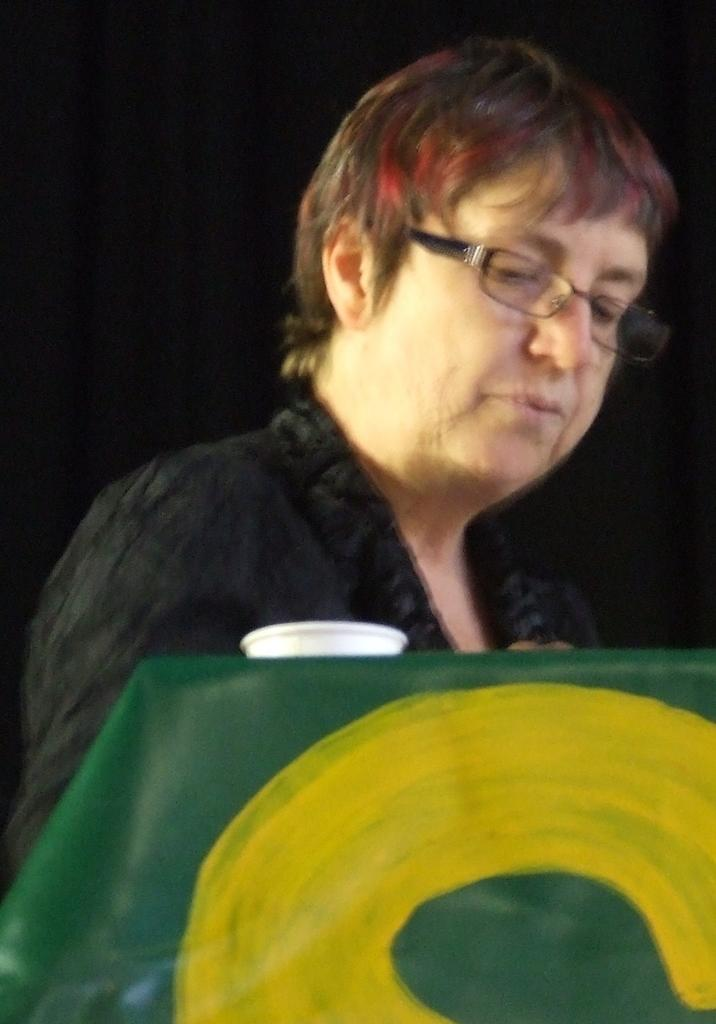Who is the main subject in the image? There is a woman in the image. What is the color of the background in the image? The background of the image is black. What is the woman doing in the image? The woman is looking downwards. Can you see a tiger in the image? No, there is no tiger present in the image. What is the woman doing to expand her knowledge in the image? The provided facts do not mention anything about the woman expanding her knowledge or any related activity. 